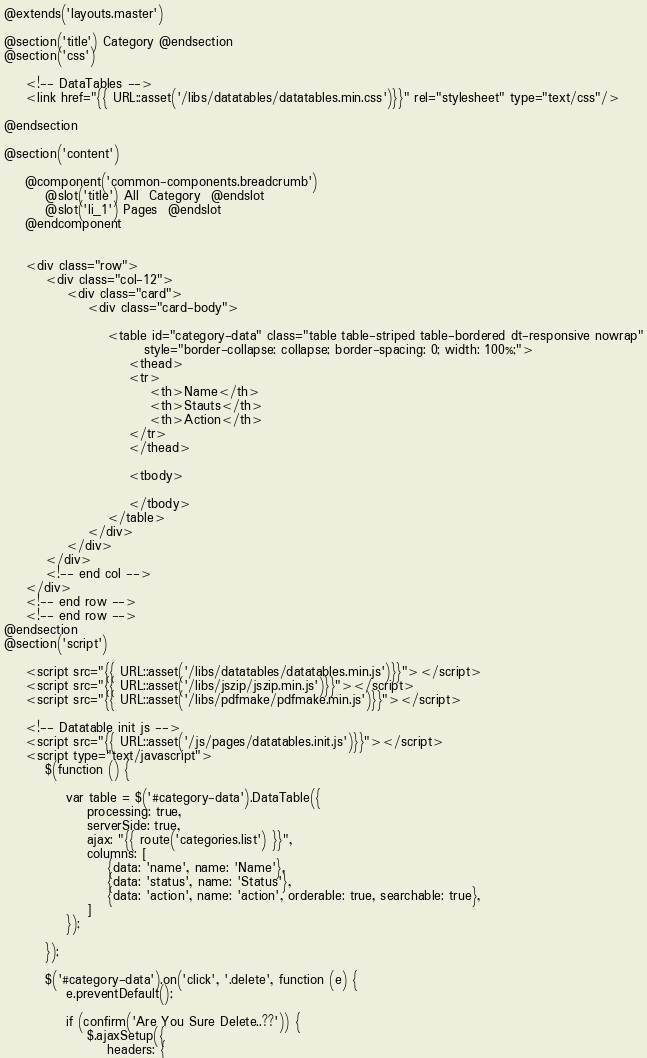Convert code to text. <code><loc_0><loc_0><loc_500><loc_500><_PHP_>@extends('layouts.master')

@section('title') Category @endsection
@section('css')

    <!-- DataTables -->
    <link href="{{ URL::asset('/libs/datatables/datatables.min.css')}}" rel="stylesheet" type="text/css"/>

@endsection

@section('content')

    @component('common-components.breadcrumb')
        @slot('title') All  Category  @endslot
        @slot('li_1') Pages  @endslot
    @endcomponent


    <div class="row">
        <div class="col-12">
            <div class="card">
                <div class="card-body">

                    <table id="category-data" class="table table-striped table-bordered dt-responsive nowrap"
                           style="border-collapse: collapse; border-spacing: 0; width: 100%;">
                        <thead>
                        <tr>
                            <th>Name</th>
                            <th>Stauts</th>
                            <th>Action</th>
                        </tr>
                        </thead>

                        <tbody>

                        </tbody>
                    </table>
                </div>
            </div>
        </div>
        <!-- end col -->
    </div>
    <!-- end row -->
    <!-- end row -->
@endsection
@section('script')

    <script src="{{ URL::asset('/libs/datatables/datatables.min.js')}}"></script>
    <script src="{{ URL::asset('/libs/jszip/jszip.min.js')}}"></script>
    <script src="{{ URL::asset('/libs/pdfmake/pdfmake.min.js')}}"></script>

    <!-- Datatable init js -->
    <script src="{{ URL::asset('/js/pages/datatables.init.js')}}"></script>
    <script type="text/javascript">
        $(function () {

            var table = $('#category-data').DataTable({
                processing: true,
                serverSide: true,
                ajax: "{{ route('categories.list') }}",
                columns: [
                    {data: 'name', name: 'Name'},
                    {data: 'status', name: 'Status'},
                    {data: 'action', name: 'action', orderable: true, searchable: true},
                ]
            });

        });

        $('#category-data').on('click', '.delete', function (e) {
            e.preventDefault();

            if (confirm('Are You Sure Delete..??')) {
                $.ajaxSetup({
                    headers: {</code> 